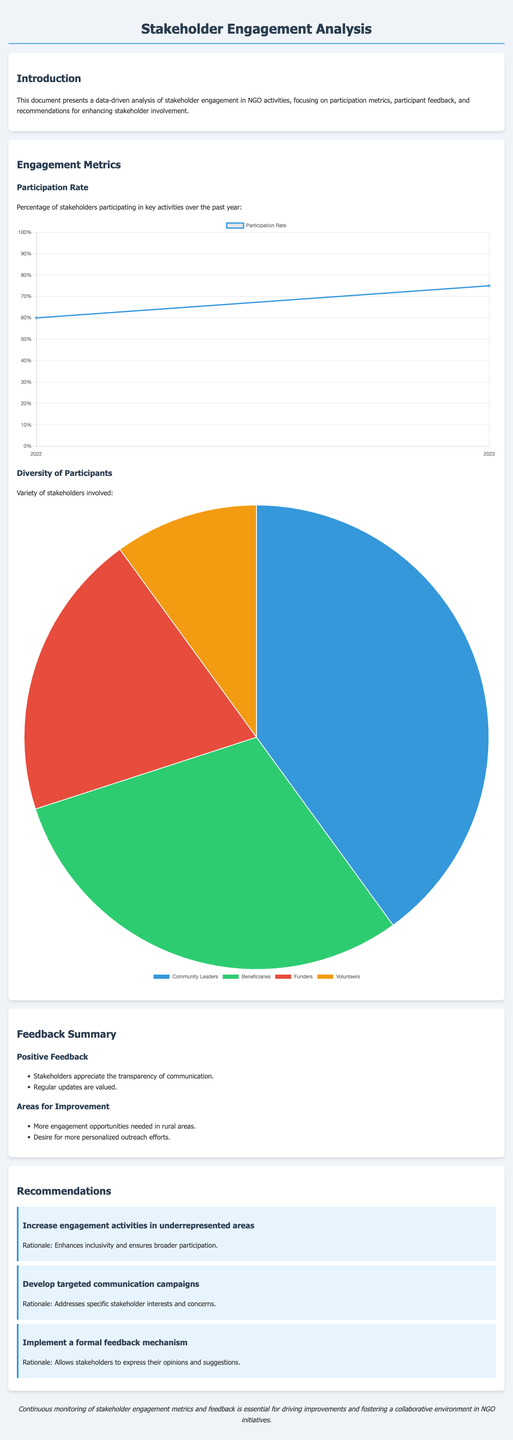What is the participation rate for 2022? The participation rate for 2022 is indicated in the chart, which shows the value of 60.
Answer: 60 What is the participation rate for 2023? The participation rate for 2023 is represented in the chart, which shows the value of 75.
Answer: 75 What percentage of participants are Community Leaders? The pie chart shows that Community Leaders represent 40 percent of the participants.
Answer: 40 What is the main area for improvement identified in the feedback summary? The main area for improvement highlighted in the feedback summary is the need for more engagement opportunities in rural areas.
Answer: More engagement opportunities in rural areas What is one of the recommendations provided in the document? One recommendation from the document is to increase engagement activities in underrepresented areas, aimed at enhancing inclusivity.
Answer: Increase engagement activities in underrepresented areas What is the total number of participant categories in the diversity chart? The diversity chart includes four categories of participants - Community Leaders, Beneficiaries, Funders, and Volunteers.
Answer: Four What does the document emphasize for ongoing improvement? The document emphasizes the importance of continuous monitoring of stakeholder engagement metrics and feedback for driving improvements.
Answer: Continuous monitoring of stakeholder engagement metrics What is the feedback regarding communications appreciated by stakeholders? Stakeholders express appreciation for the transparency of communication as indicated in the positive feedback section.
Answer: Transparency of communication What type of chart is used to represent the participation rate? A line chart is used to represent the participation rate in the document.
Answer: Line chart 